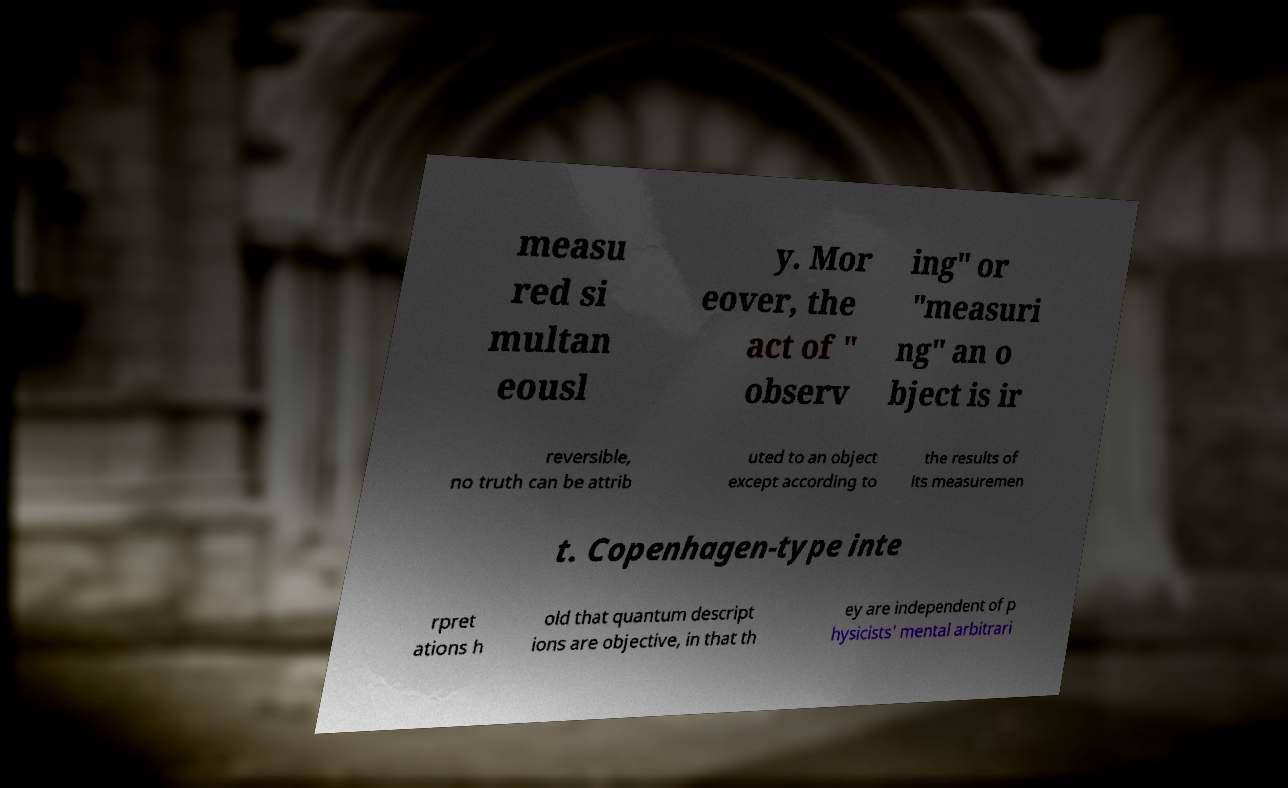For documentation purposes, I need the text within this image transcribed. Could you provide that? measu red si multan eousl y. Mor eover, the act of " observ ing" or "measuri ng" an o bject is ir reversible, no truth can be attrib uted to an object except according to the results of its measuremen t. Copenhagen-type inte rpret ations h old that quantum descript ions are objective, in that th ey are independent of p hysicists' mental arbitrari 